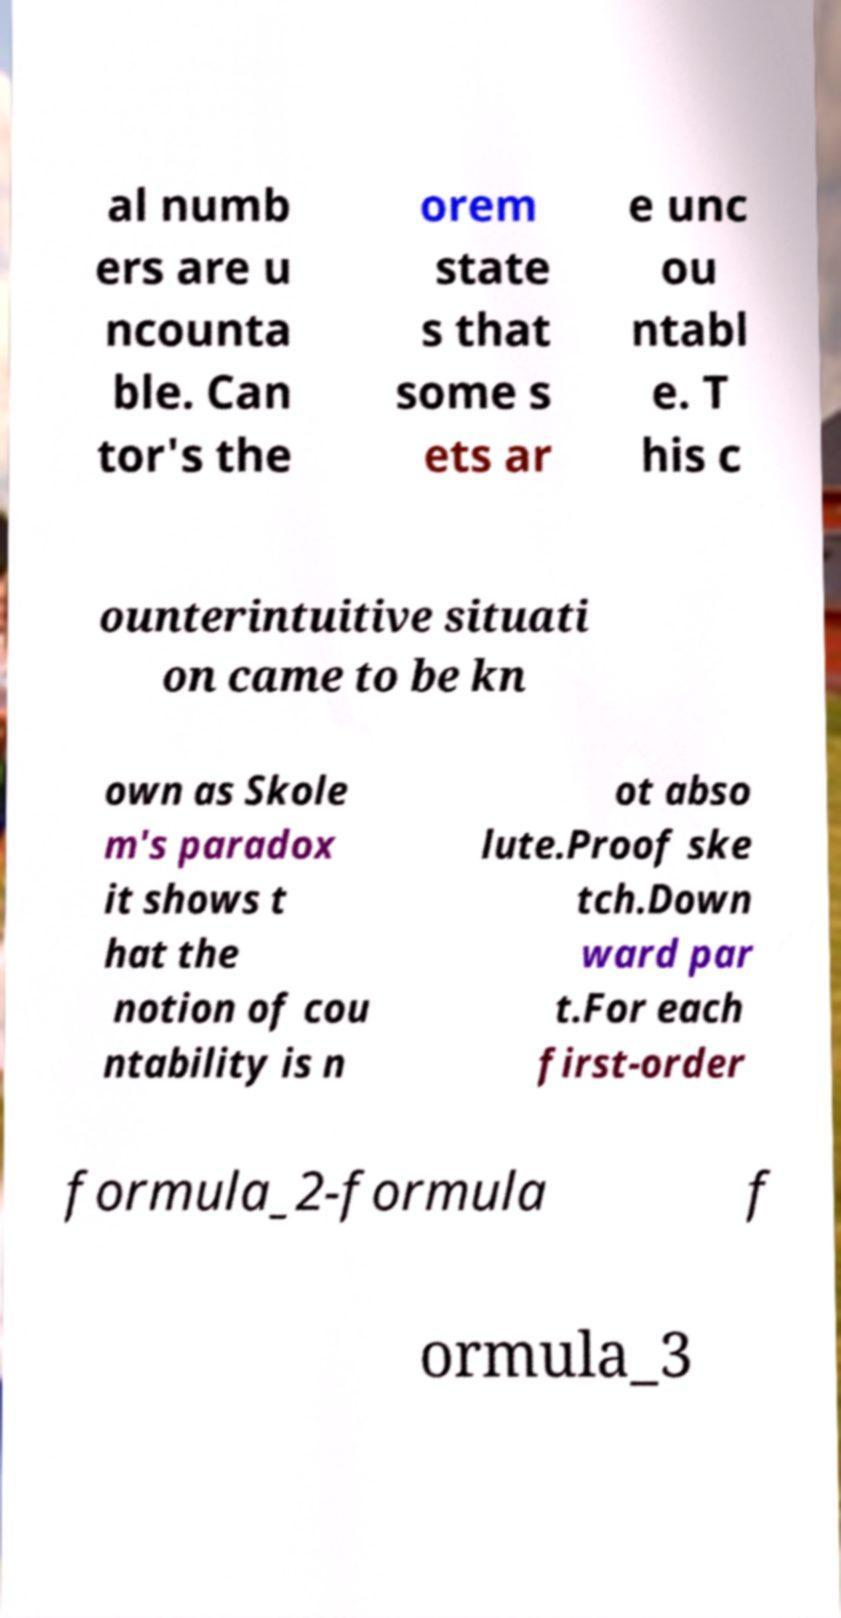Please read and relay the text visible in this image. What does it say? al numb ers are u ncounta ble. Can tor's the orem state s that some s ets ar e unc ou ntabl e. T his c ounterintuitive situati on came to be kn own as Skole m's paradox it shows t hat the notion of cou ntability is n ot abso lute.Proof ske tch.Down ward par t.For each first-order formula_2-formula f ormula_3 